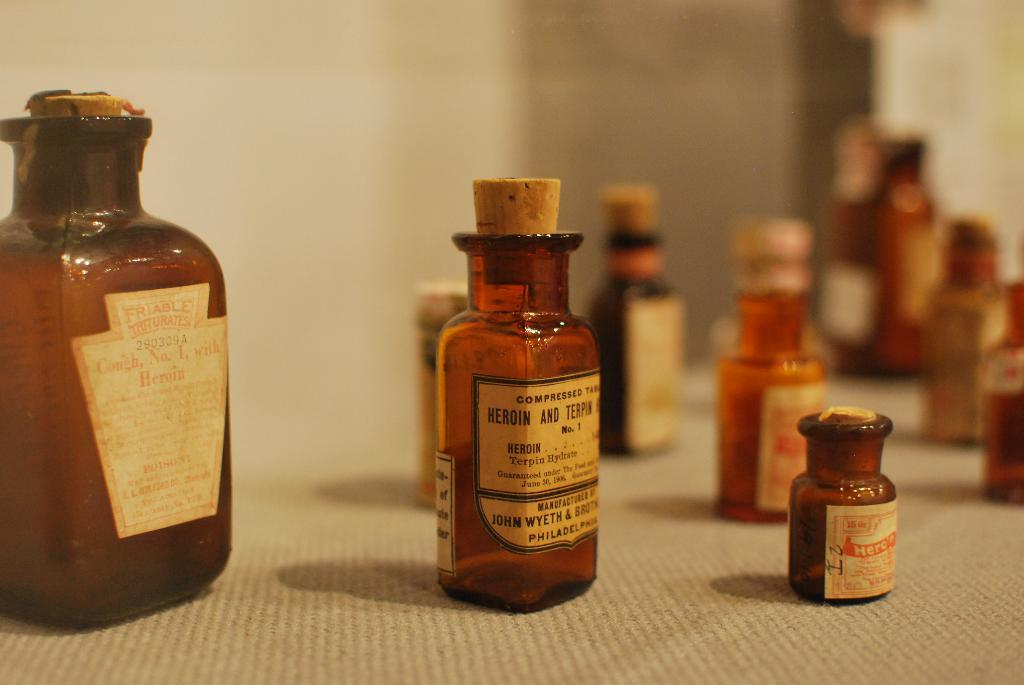<image>
Describe the image concisely. John Wyeth and Brothers manufactured heroin and terpin compressed tablets 